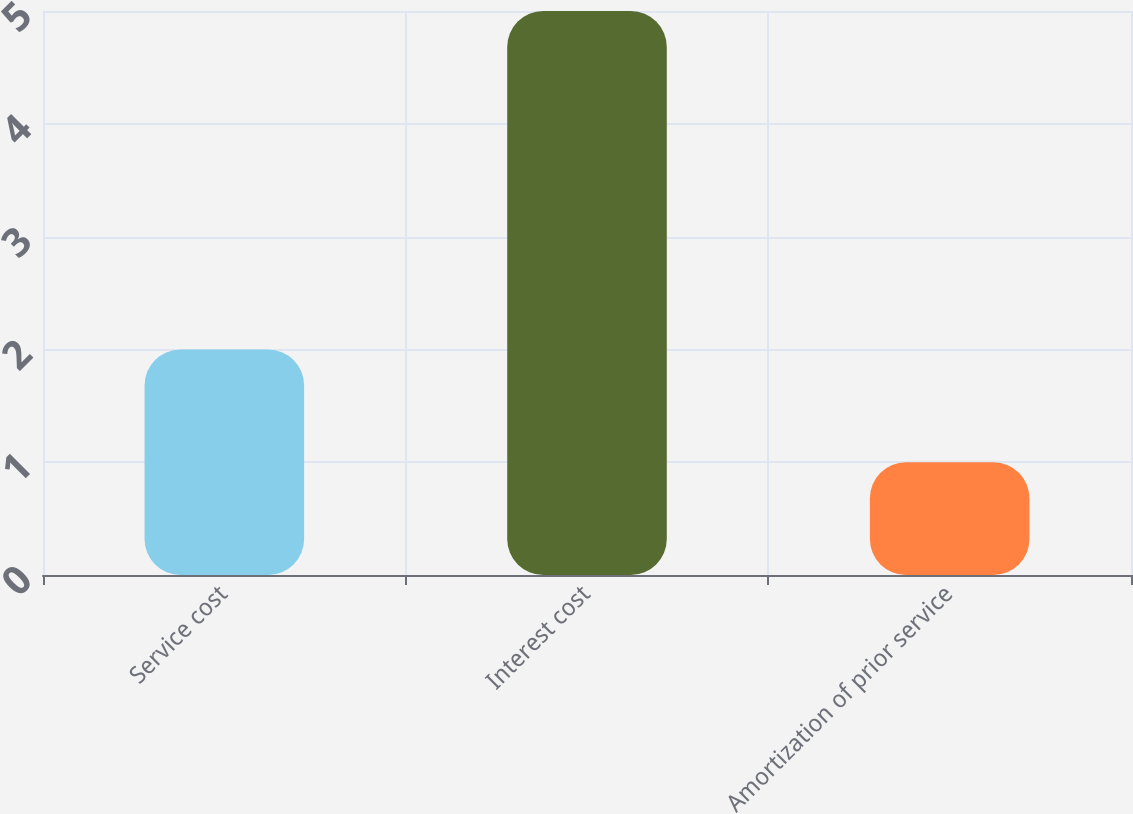<chart> <loc_0><loc_0><loc_500><loc_500><bar_chart><fcel>Service cost<fcel>Interest cost<fcel>Amortization of prior service<nl><fcel>2<fcel>5<fcel>1<nl></chart> 